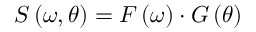<formula> <loc_0><loc_0><loc_500><loc_500>S \left ( \omega , \theta \right ) = F \left ( \omega \right ) \cdot G \left ( \theta \right )</formula> 